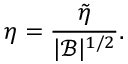Convert formula to latex. <formula><loc_0><loc_0><loc_500><loc_500>\eta = \frac { \tilde { \eta } } { | \mathcal { B } | ^ { 1 / 2 } } .</formula> 